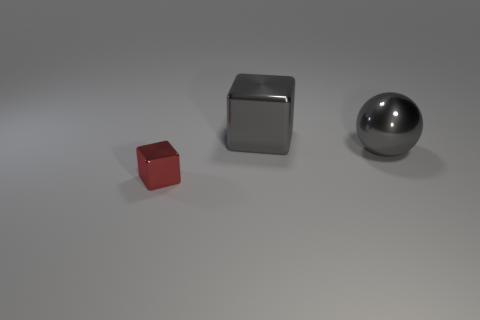Are there an equal number of tiny metallic things that are on the left side of the small metal block and blue metal balls? Yes, upon examining the image, there is indeed an equal number of metallic objects to the left side of the small metal block as there are blue metal balls, which is zero. There are no tiny metallic things on the left, and no blue metal balls present in the image at all. 